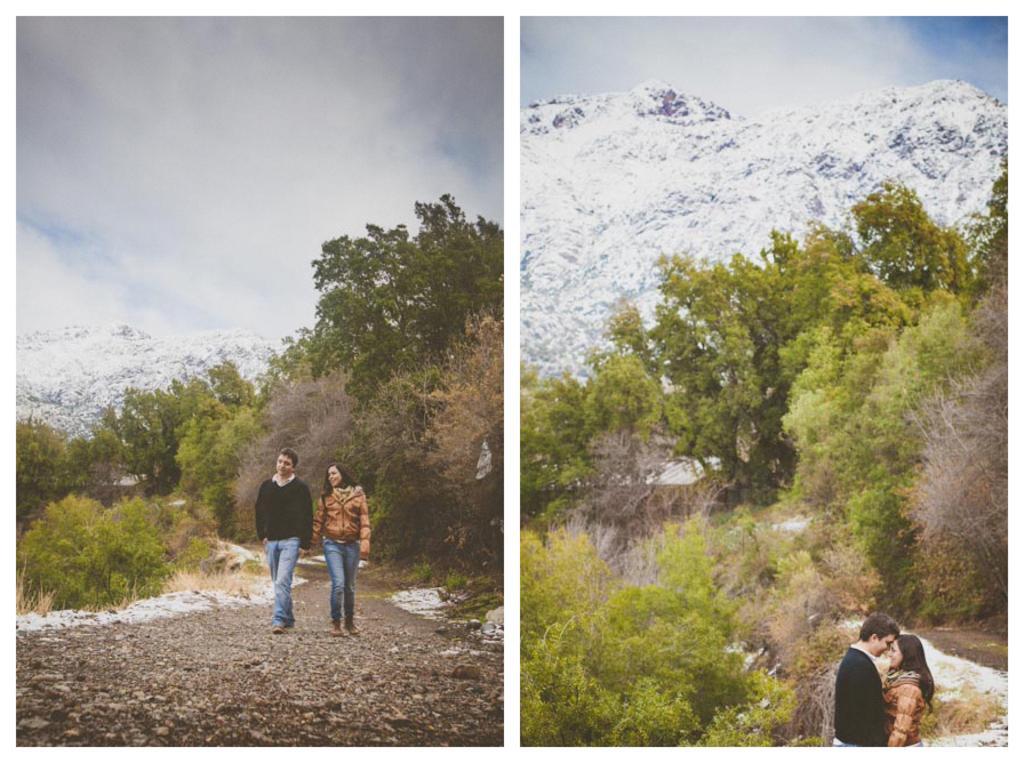Can you describe this image briefly? In this image I can see a collage picture and I can also see few persons walking. The person at right is wearing brown jacket, blue pant and the person at left is wearing black shirt, blue pant. Background I can see few trees in green color, snow in white color and the sky is in white and blue color. 